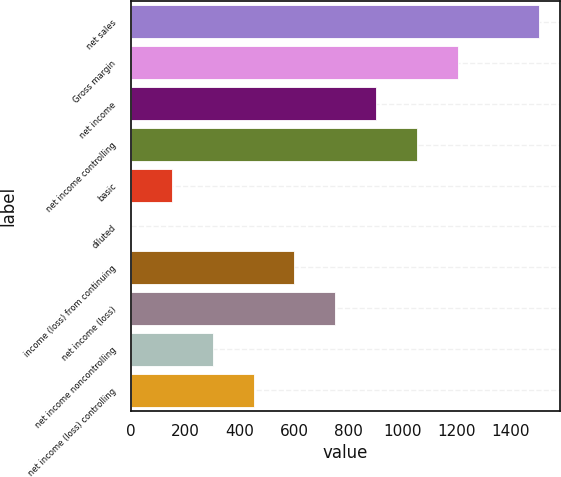Convert chart to OTSL. <chart><loc_0><loc_0><loc_500><loc_500><bar_chart><fcel>net sales<fcel>Gross margin<fcel>net income<fcel>net income controlling<fcel>basic<fcel>diluted<fcel>income (loss) from continuing<fcel>net income (loss)<fcel>net income noncontrolling<fcel>net income (loss) controlling<nl><fcel>1504.3<fcel>1203.49<fcel>902.71<fcel>1053.1<fcel>150.76<fcel>0.37<fcel>601.93<fcel>752.32<fcel>301.15<fcel>451.54<nl></chart> 